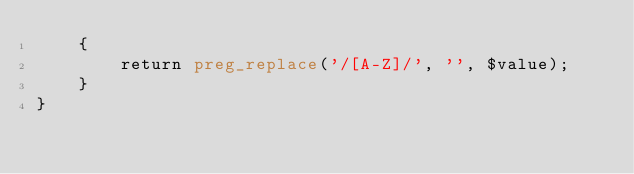Convert code to text. <code><loc_0><loc_0><loc_500><loc_500><_PHP_>    {
        return preg_replace('/[A-Z]/', '', $value);
    }
}
</code> 